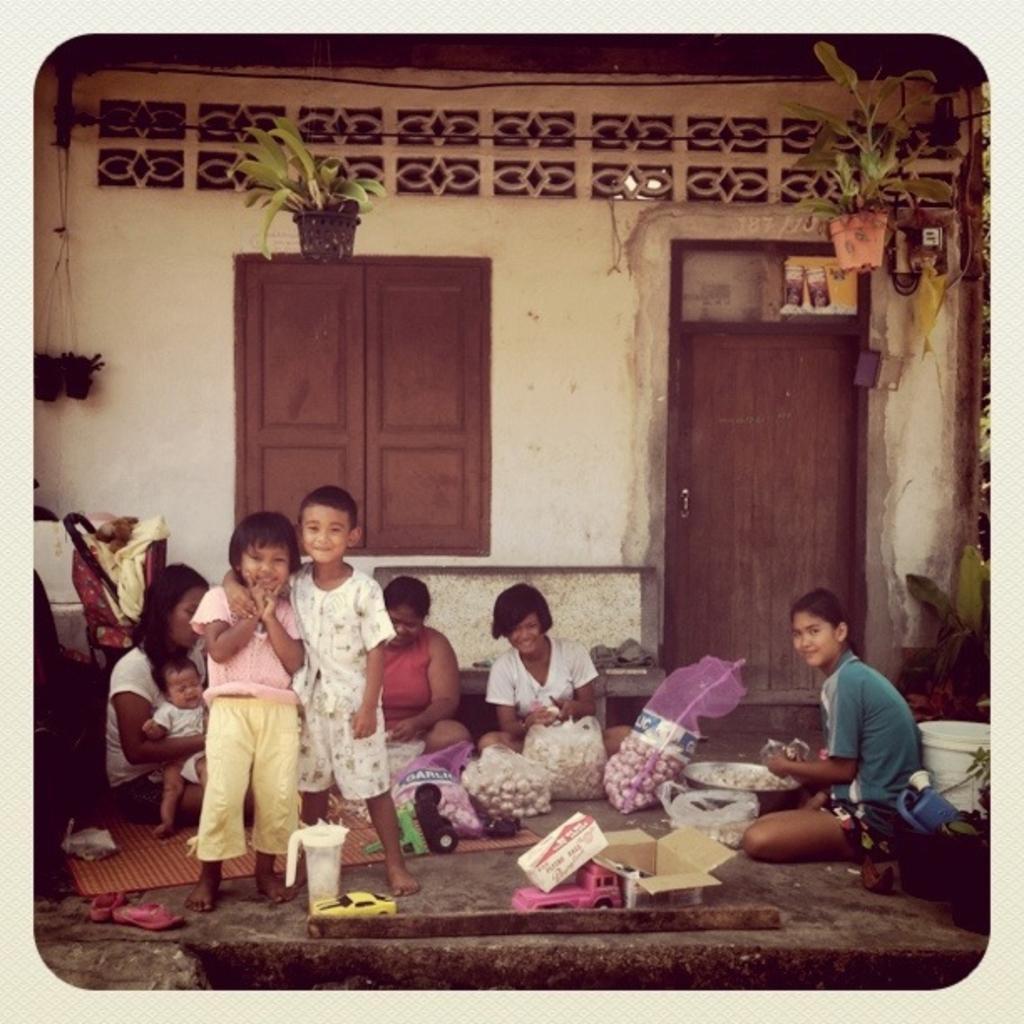In one or two sentences, can you explain what this image depicts? In this image I can see a group of people among which two kids are standing and posing for the picture and I can see a door and a window and some potted plants in the picture and I can see garlic bags in the center of the image and some toys. 